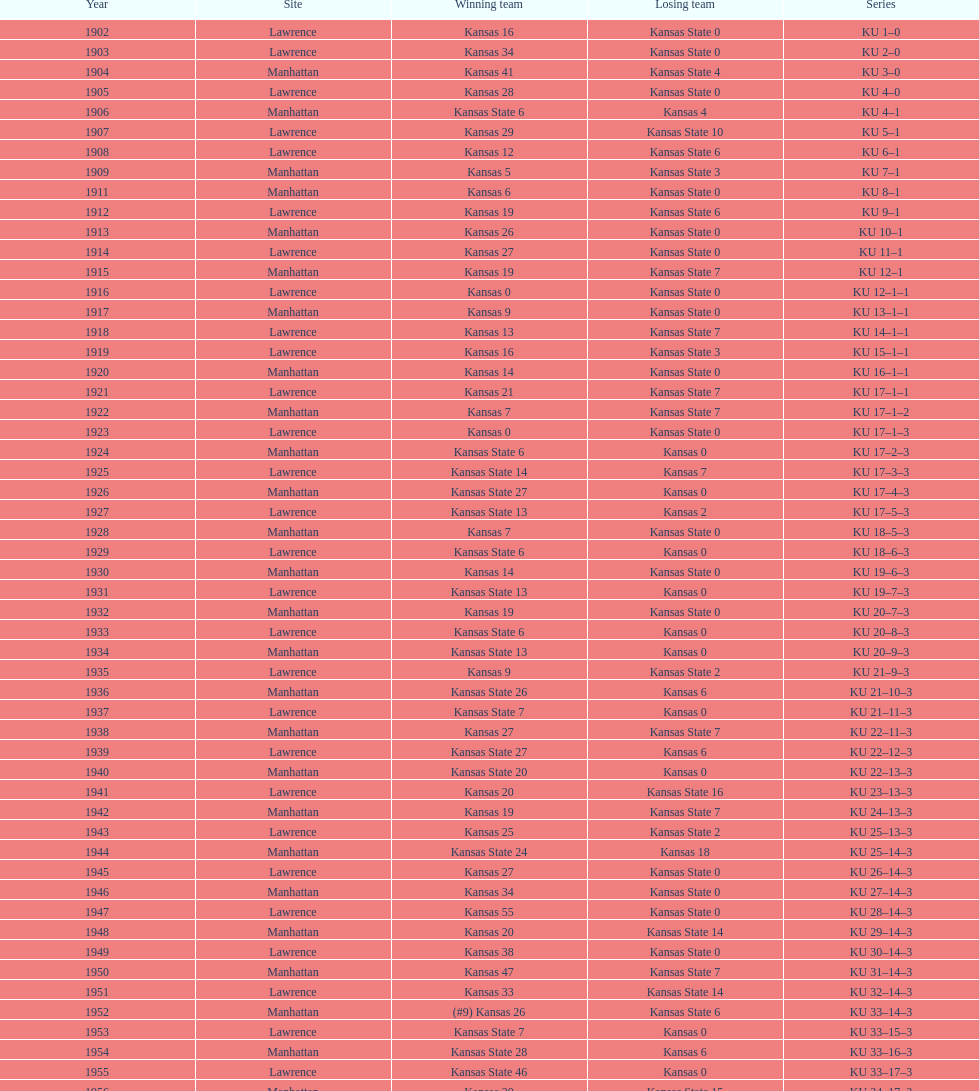When did kansas state last experience a loss with a score of zero points in manhattan? 1964. 